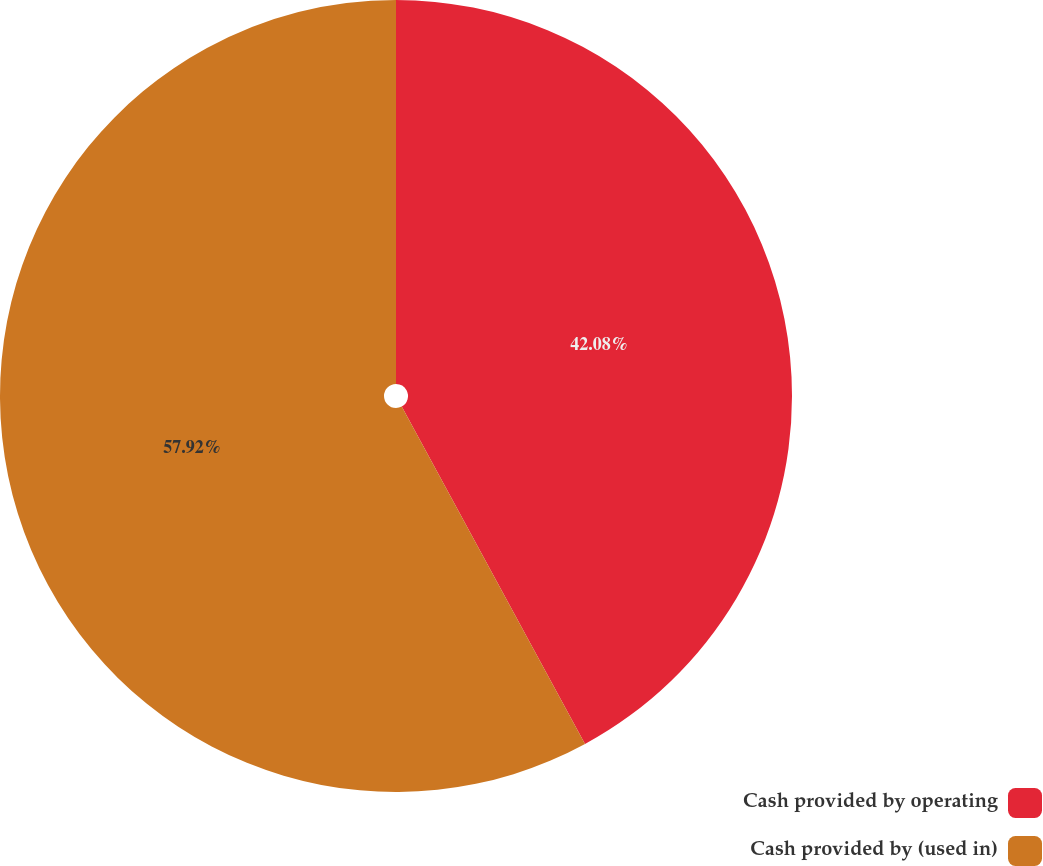Convert chart. <chart><loc_0><loc_0><loc_500><loc_500><pie_chart><fcel>Cash provided by operating<fcel>Cash provided by (used in)<nl><fcel>42.08%<fcel>57.92%<nl></chart> 